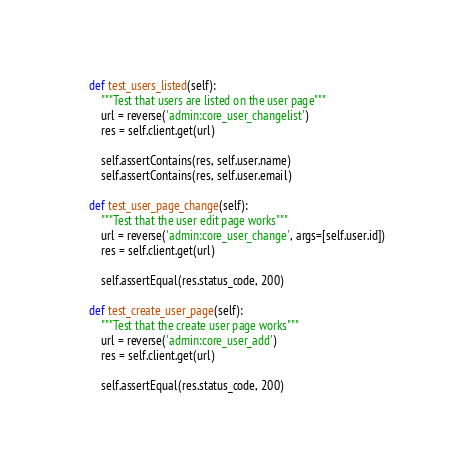Convert code to text. <code><loc_0><loc_0><loc_500><loc_500><_Python_>    def test_users_listed(self):
        """Test that users are listed on the user page"""
        url = reverse('admin:core_user_changelist')
        res = self.client.get(url)

        self.assertContains(res, self.user.name)
        self.assertContains(res, self.user.email)
    
    def test_user_page_change(self):
        """Test that the user edit page works"""
        url = reverse('admin:core_user_change', args=[self.user.id])
        res = self.client.get(url)

        self.assertEqual(res.status_code, 200)
    
    def test_create_user_page(self):
        """Test that the create user page works"""
        url = reverse('admin:core_user_add')
        res = self.client.get(url)

        self.assertEqual(res.status_code, 200)</code> 